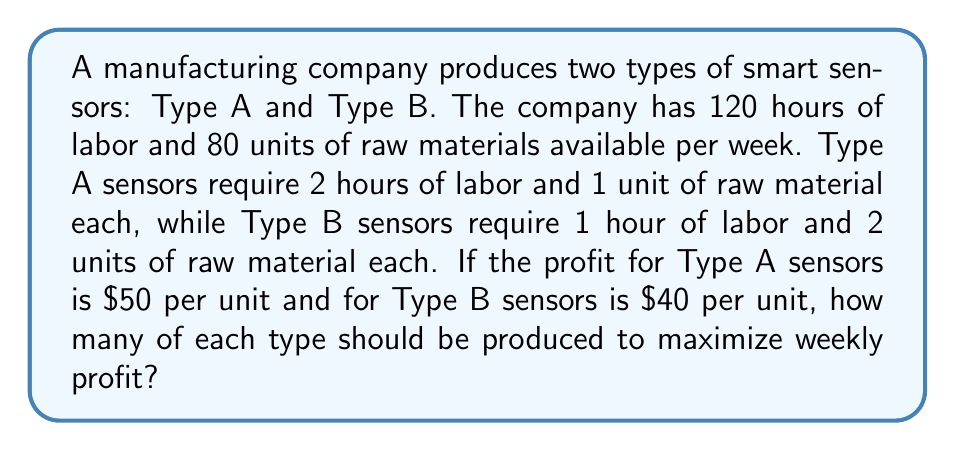Provide a solution to this math problem. Let's approach this step-by-step:

1) Define variables:
   Let $x$ = number of Type A sensors
   Let $y$ = number of Type B sensors

2) Set up constraints based on available resources:
   Labor constraint: $2x + y \leq 120$
   Raw material constraint: $x + 2y \leq 80$

3) Define the profit function:
   $P = 50x + 40y$

4) To maximize profit, we need to find the optimal point where these constraints intersect. We can solve this system of equations:

   $2x + y = 120$
   $x + 2y = 80$

5) Multiply the second equation by 2:
   $2x + y = 120$
   $2x + 4y = 160$

6) Subtract the first equation from the second:
   $3y = 40$
   $y = \frac{40}{3} \approx 13.33$

7) Substitute this value of $y$ back into $2x + y = 120$:
   $2x + 13.33 = 120$
   $2x = 106.67$
   $x = 53.33$

8) Since we can't produce fractional sensors, we round down to the nearest whole number:
   $x = 53$ (Type A sensors)
   $y = 13$ (Type B sensors)

9) Verify that this solution satisfies both constraints:
   Labor: $2(53) + 13 = 119 \leq 120$
   Raw material: $53 + 2(13) = 79 \leq 80$

10) Calculate the maximum profit:
    $P = 50(53) + 40(13) = 2650 + 520 = 3170$
Answer: 53 Type A sensors, 13 Type B sensors; Maximum profit: $3170 